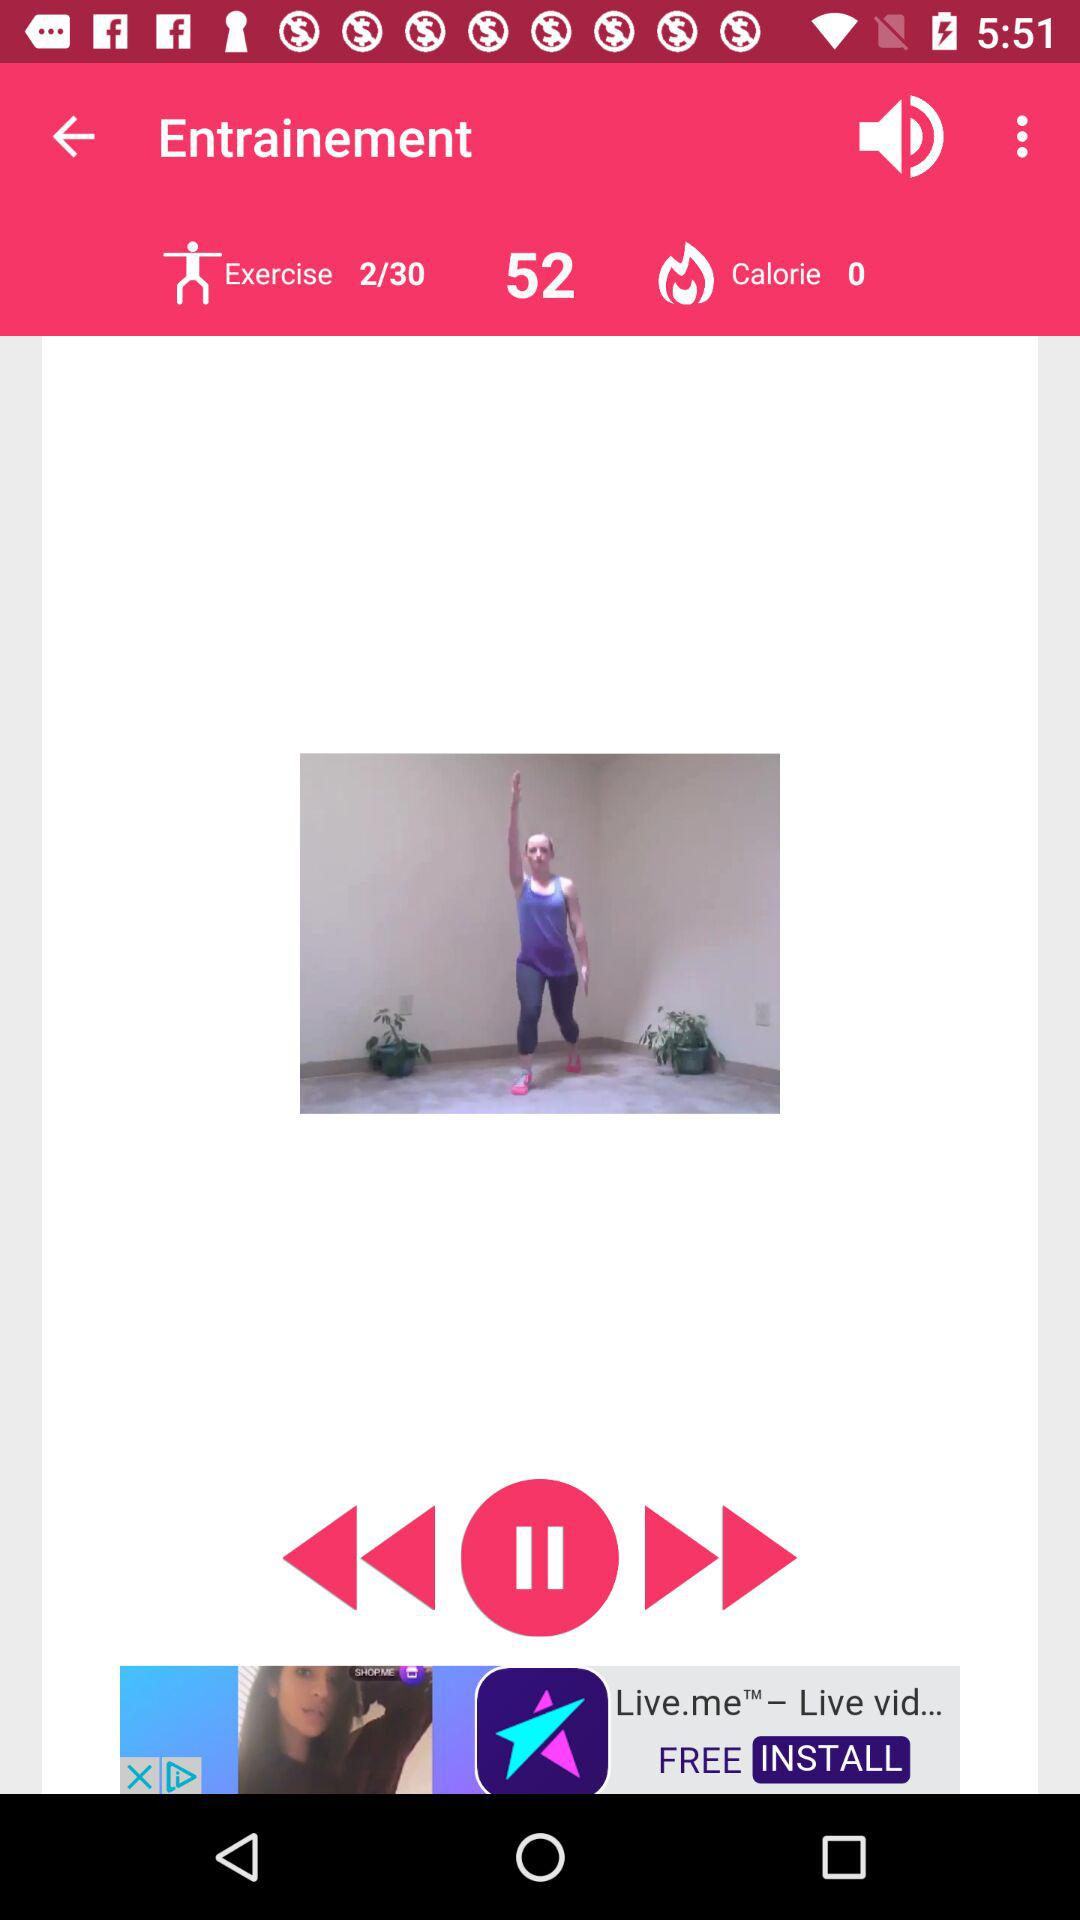How many calories are you burning?
Answer the question using a single word or phrase. 0 